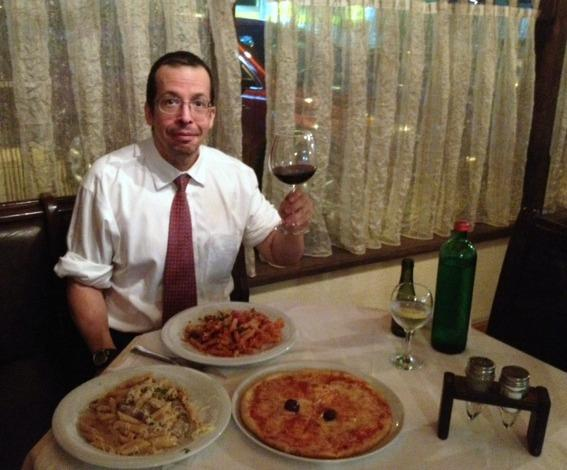Who does the person most look like? man 